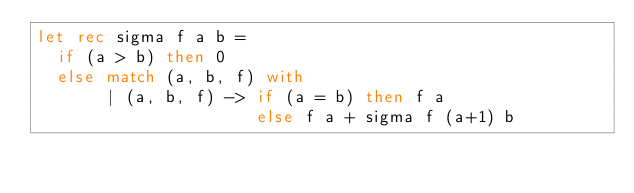<code> <loc_0><loc_0><loc_500><loc_500><_OCaml_>let rec sigma f a b =
  if (a > b) then 0
  else match (a, b, f) with
       | (a, b, f) -> if (a = b) then f a
                      else f a + sigma f (a+1) b
</code> 